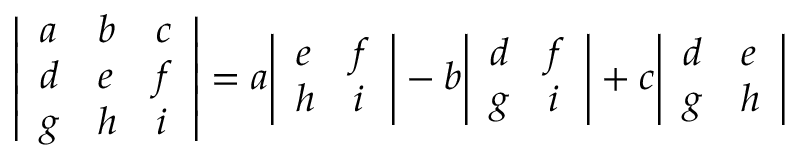<formula> <loc_0><loc_0><loc_500><loc_500>{ \left | \begin{array} { l l l } { a } & { b } & { c } \\ { d } & { e } & { f } \\ { g } & { h } & { i } \end{array} \right | } = a { \left | \begin{array} { l l } { e } & { f } \\ { h } & { i } \end{array} \right | } - b { \left | \begin{array} { l l } { d } & { f } \\ { g } & { i } \end{array} \right | } + c { \left | \begin{array} { l l } { d } & { e } \\ { g } & { h } \end{array} \right | }</formula> 